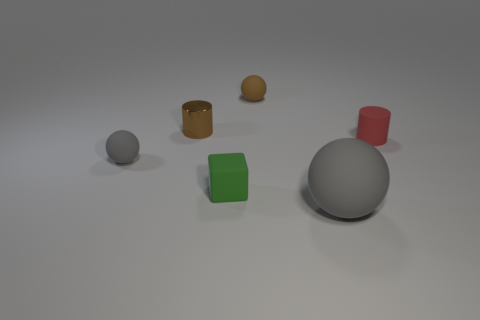Subtract all brown spheres. Subtract all cyan cylinders. How many spheres are left? 2 Add 1 spheres. How many objects exist? 7 Subtract all cylinders. How many objects are left? 4 Subtract all tiny blocks. Subtract all tiny brown matte things. How many objects are left? 4 Add 5 matte blocks. How many matte blocks are left? 6 Add 1 brown shiny things. How many brown shiny things exist? 2 Subtract 0 blue spheres. How many objects are left? 6 